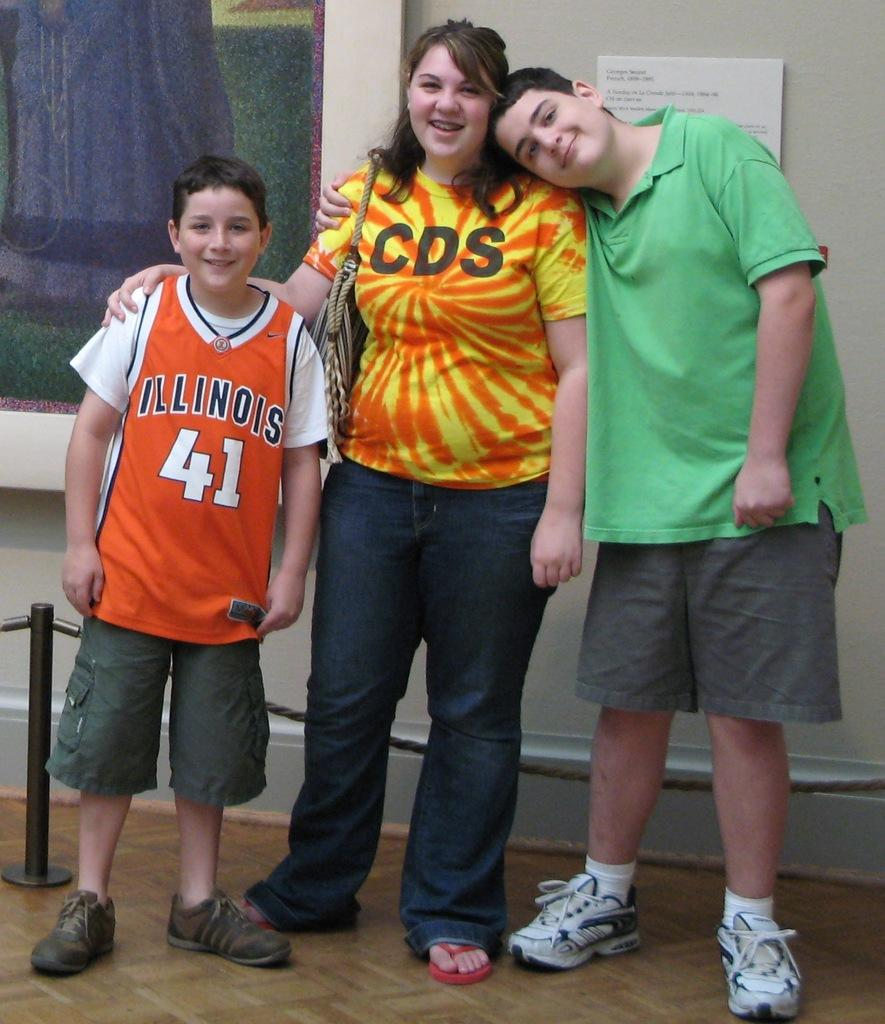<image>
Write a terse but informative summary of the picture. A woman in a CDS shirt stands with a boy in an Illinois jersey. 